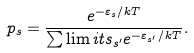Convert formula to latex. <formula><loc_0><loc_0><loc_500><loc_500>p _ { s } = \frac { e ^ { - \varepsilon _ { s } / k T } } { \sum \lim i t s _ { s ^ { \prime } } e ^ { - \varepsilon _ { s ^ { \prime } } / k T } } .</formula> 